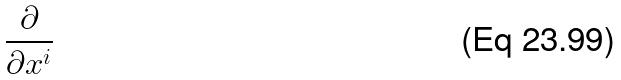Convert formula to latex. <formula><loc_0><loc_0><loc_500><loc_500>\frac { \partial } { \partial x ^ { i } }</formula> 